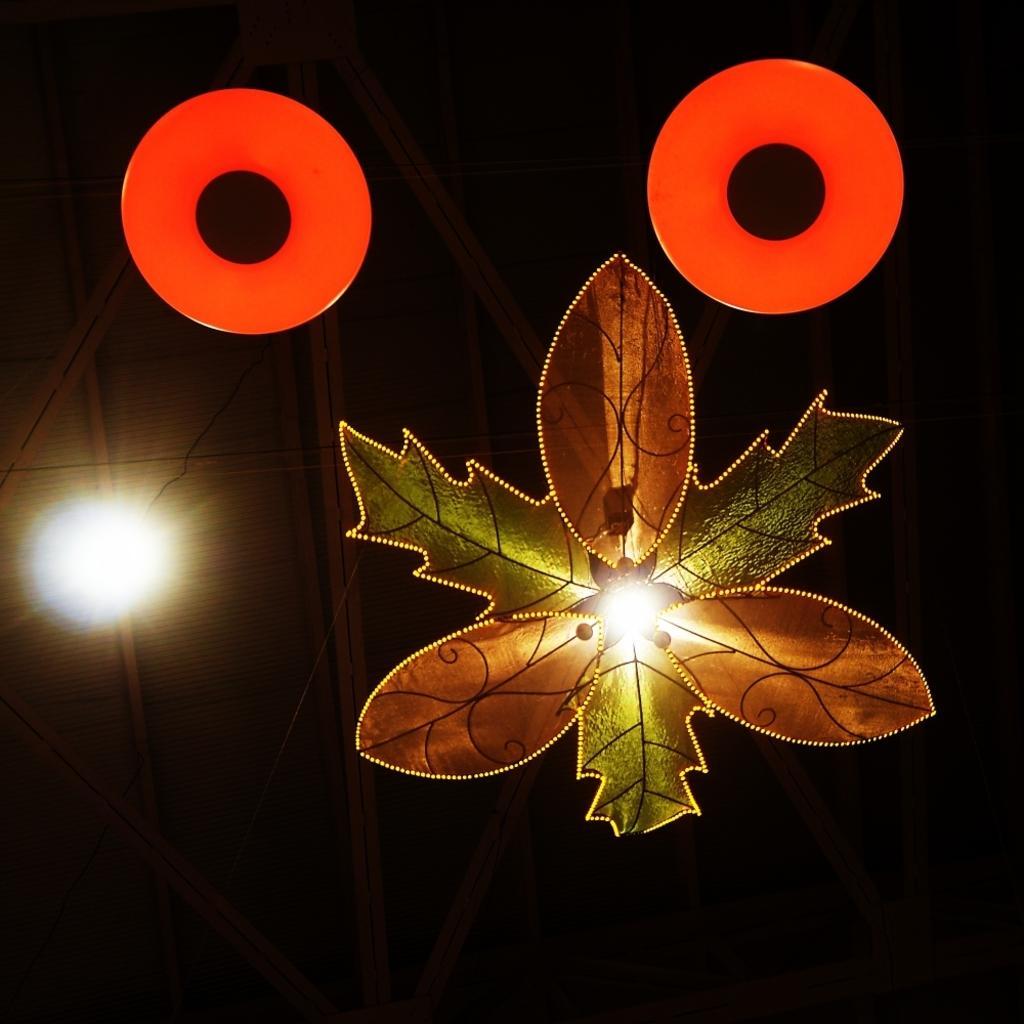Describe this image in one or two sentences. In this image we can see the leaf shaped ceiling lamp, two red color objects and the light here. The background of the image is dark. 